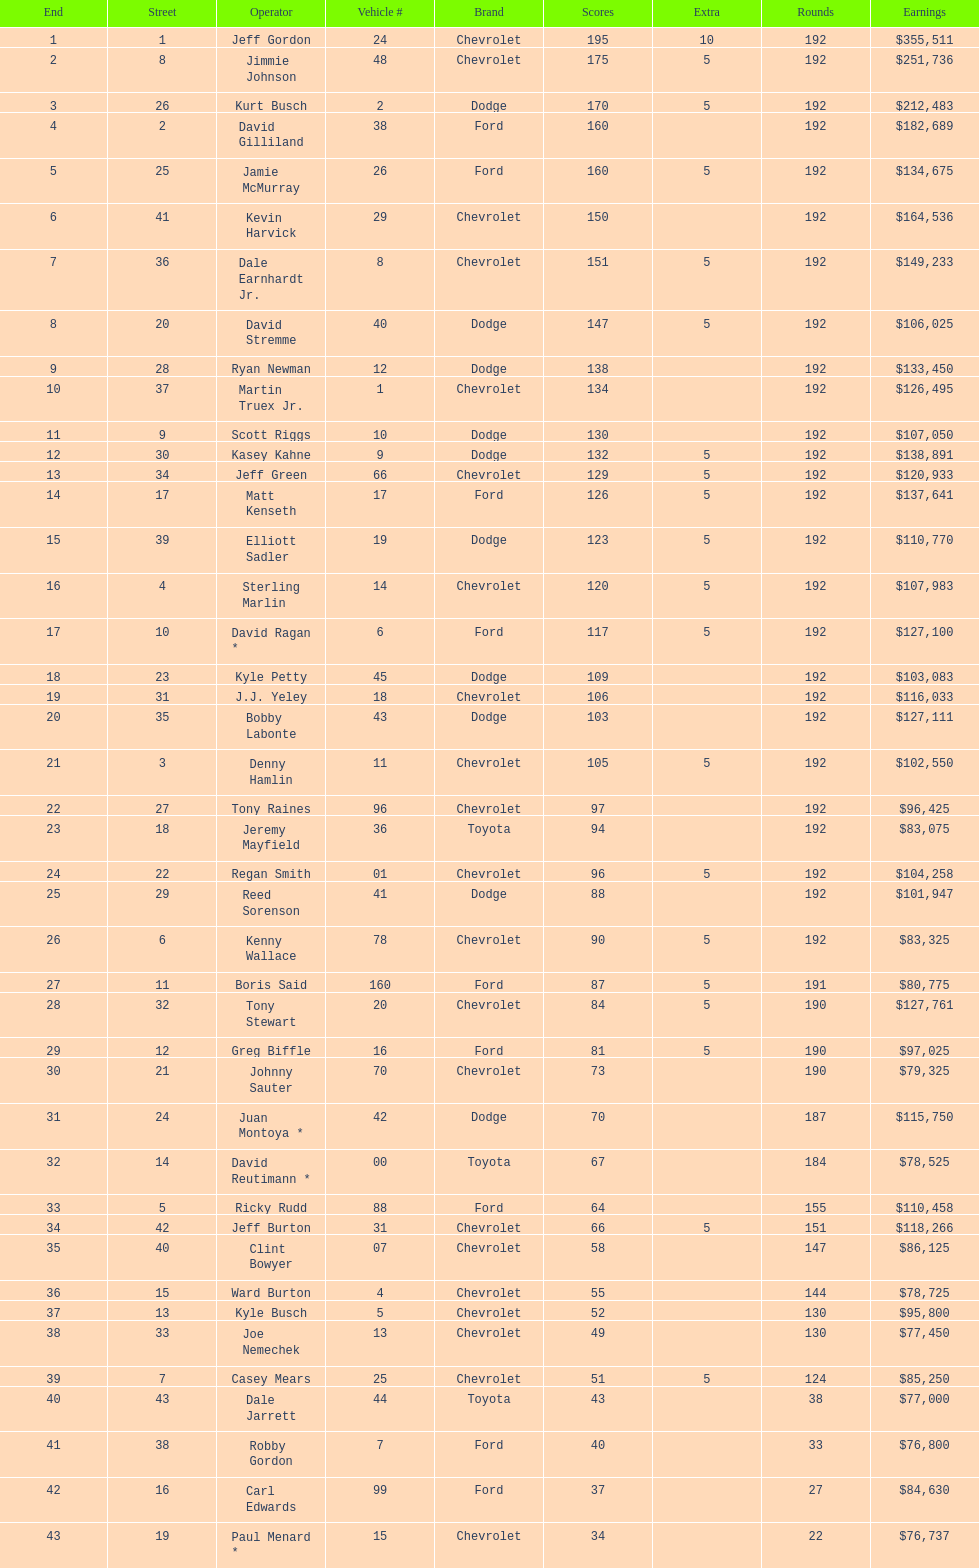How many drivers earned 5 bonus each in the race? 19. 